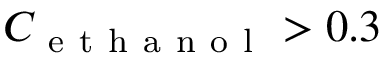Convert formula to latex. <formula><loc_0><loc_0><loc_500><loc_500>C _ { e t h a n o l } > 0 . 3</formula> 